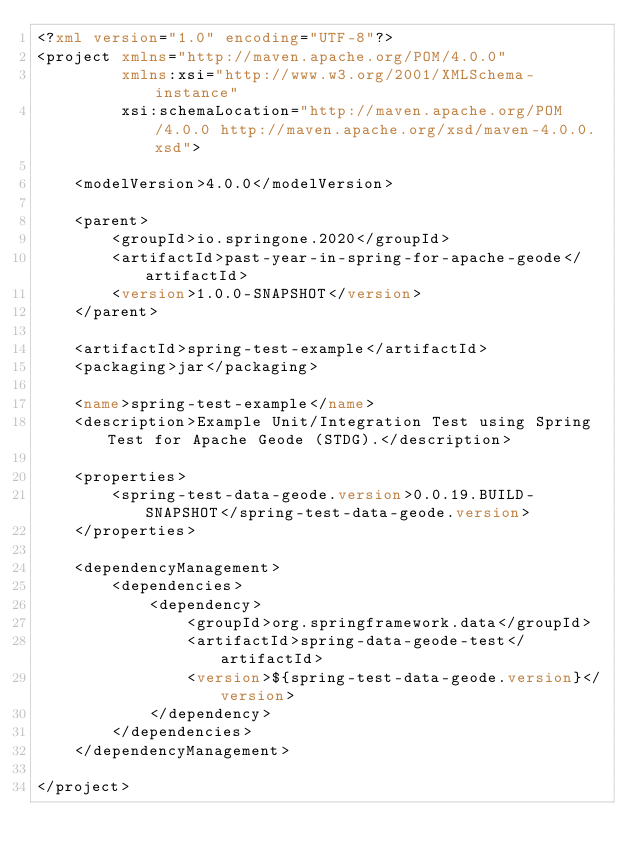<code> <loc_0><loc_0><loc_500><loc_500><_XML_><?xml version="1.0" encoding="UTF-8"?>
<project xmlns="http://maven.apache.org/POM/4.0.0"
		 xmlns:xsi="http://www.w3.org/2001/XMLSchema-instance"
		 xsi:schemaLocation="http://maven.apache.org/POM/4.0.0 http://maven.apache.org/xsd/maven-4.0.0.xsd">

	<modelVersion>4.0.0</modelVersion>

	<parent>
		<groupId>io.springone.2020</groupId>
		<artifactId>past-year-in-spring-for-apache-geode</artifactId>
		<version>1.0.0-SNAPSHOT</version>
	</parent>

	<artifactId>spring-test-example</artifactId>
	<packaging>jar</packaging>

	<name>spring-test-example</name>
	<description>Example Unit/Integration Test using Spring Test for Apache Geode (STDG).</description>

	<properties>
		<spring-test-data-geode.version>0.0.19.BUILD-SNAPSHOT</spring-test-data-geode.version>
	</properties>

	<dependencyManagement>
		<dependencies>
			<dependency>
				<groupId>org.springframework.data</groupId>
				<artifactId>spring-data-geode-test</artifactId>
				<version>${spring-test-data-geode.version}</version>
			</dependency>
		</dependencies>
	</dependencyManagement>

</project>
</code> 